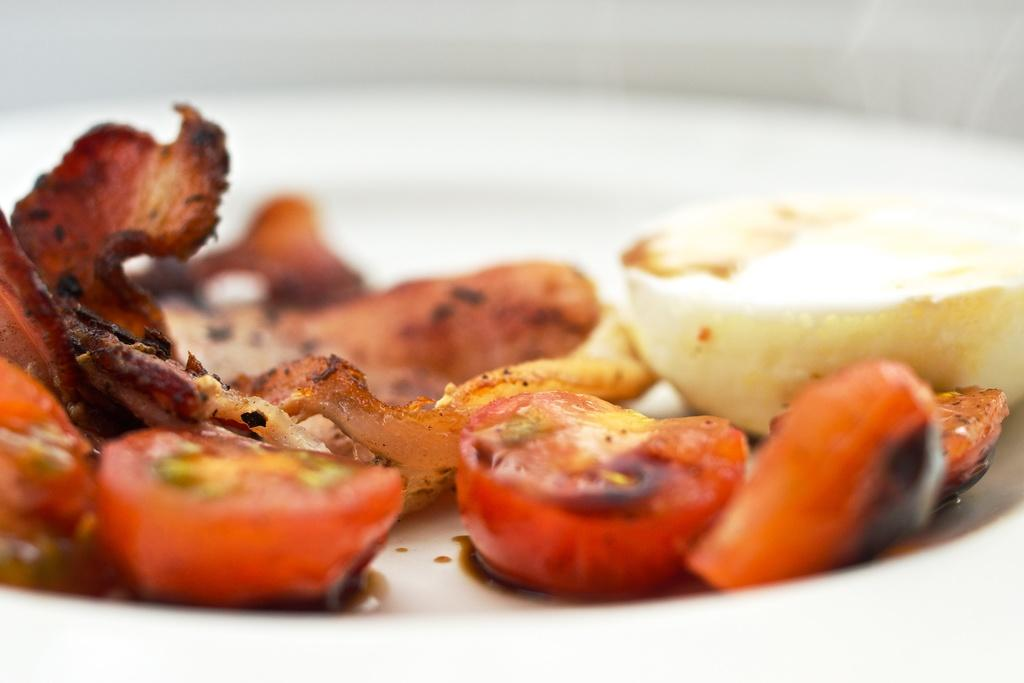What is placed on a plate in the image? There is a food item placed in a plate in the image. What type of sidewalk can be seen in the image? There is no sidewalk present in the image; it only features a food item placed on a plate. 